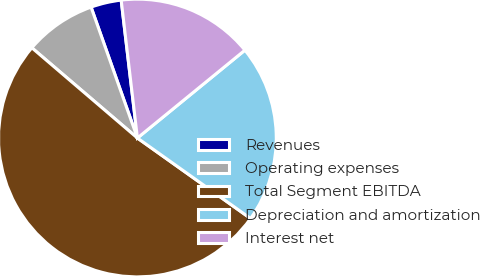<chart> <loc_0><loc_0><loc_500><loc_500><pie_chart><fcel>Revenues<fcel>Operating expenses<fcel>Total Segment EBITDA<fcel>Depreciation and amortization<fcel>Interest net<nl><fcel>3.55%<fcel>8.33%<fcel>51.42%<fcel>20.74%<fcel>15.96%<nl></chart> 